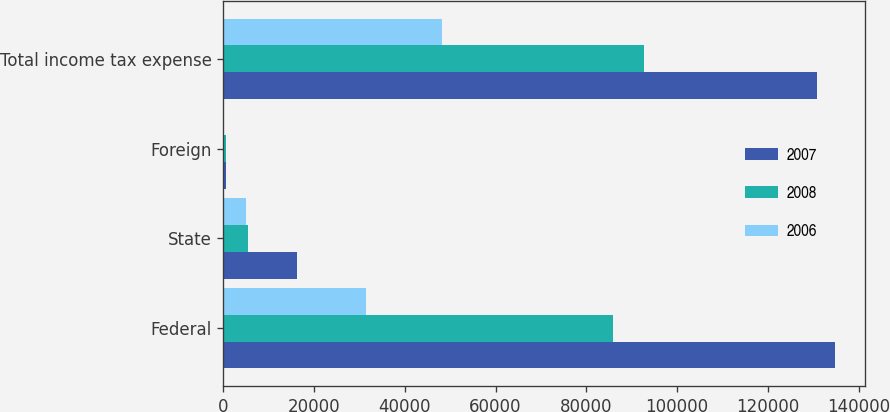Convert chart. <chart><loc_0><loc_0><loc_500><loc_500><stacked_bar_chart><ecel><fcel>Federal<fcel>State<fcel>Foreign<fcel>Total income tax expense<nl><fcel>2007<fcel>134722<fcel>16137<fcel>600<fcel>130888<nl><fcel>2008<fcel>85858<fcel>5521<fcel>590<fcel>92697<nl><fcel>2006<fcel>31543<fcel>4903<fcel>216<fcel>48094<nl></chart> 